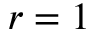Convert formula to latex. <formula><loc_0><loc_0><loc_500><loc_500>r = 1</formula> 